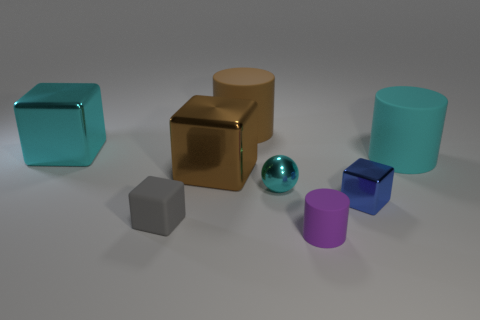Subtract all rubber cubes. How many cubes are left? 3 Subtract all blue blocks. How many blocks are left? 3 Add 2 big green matte objects. How many objects exist? 10 Subtract all balls. How many objects are left? 7 Add 7 big brown cylinders. How many big brown cylinders exist? 8 Subtract 0 green cylinders. How many objects are left? 8 Subtract all purple balls. Subtract all red cylinders. How many balls are left? 1 Subtract all green shiny objects. Subtract all shiny things. How many objects are left? 4 Add 4 big brown matte objects. How many big brown matte objects are left? 5 